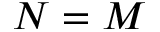Convert formula to latex. <formula><loc_0><loc_0><loc_500><loc_500>N = M</formula> 